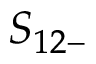<formula> <loc_0><loc_0><loc_500><loc_500>S _ { 1 2 - }</formula> 